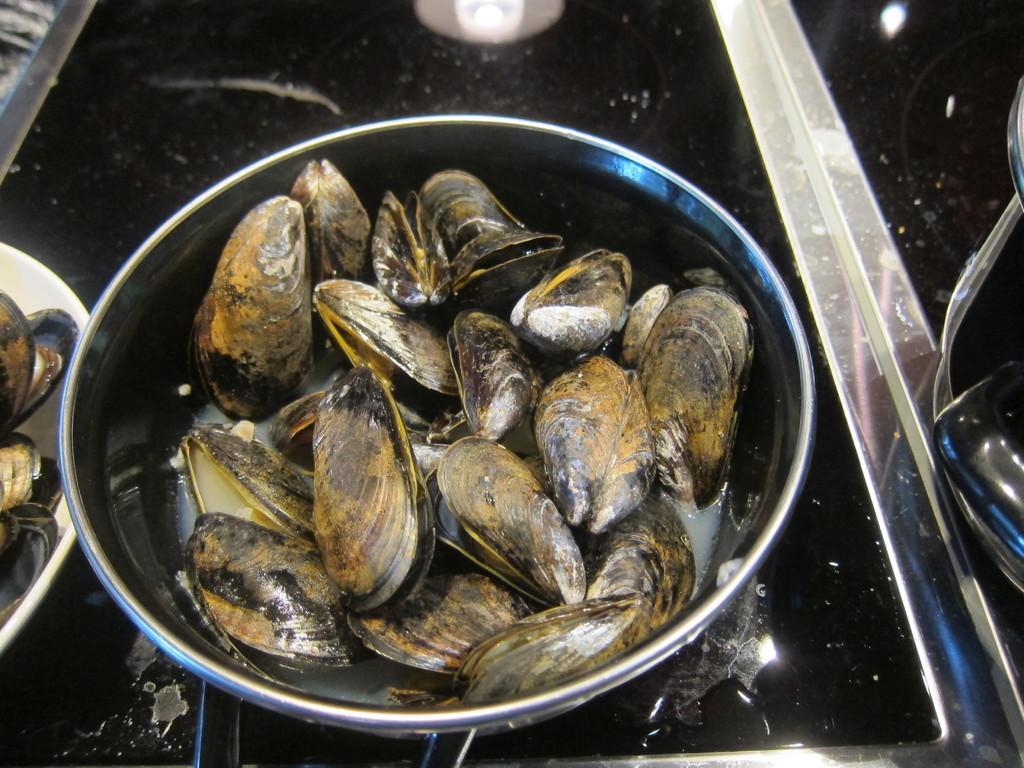Describe this image in one or two sentences. In this image there are bowls on a surface. There are oysters in the bowls. 